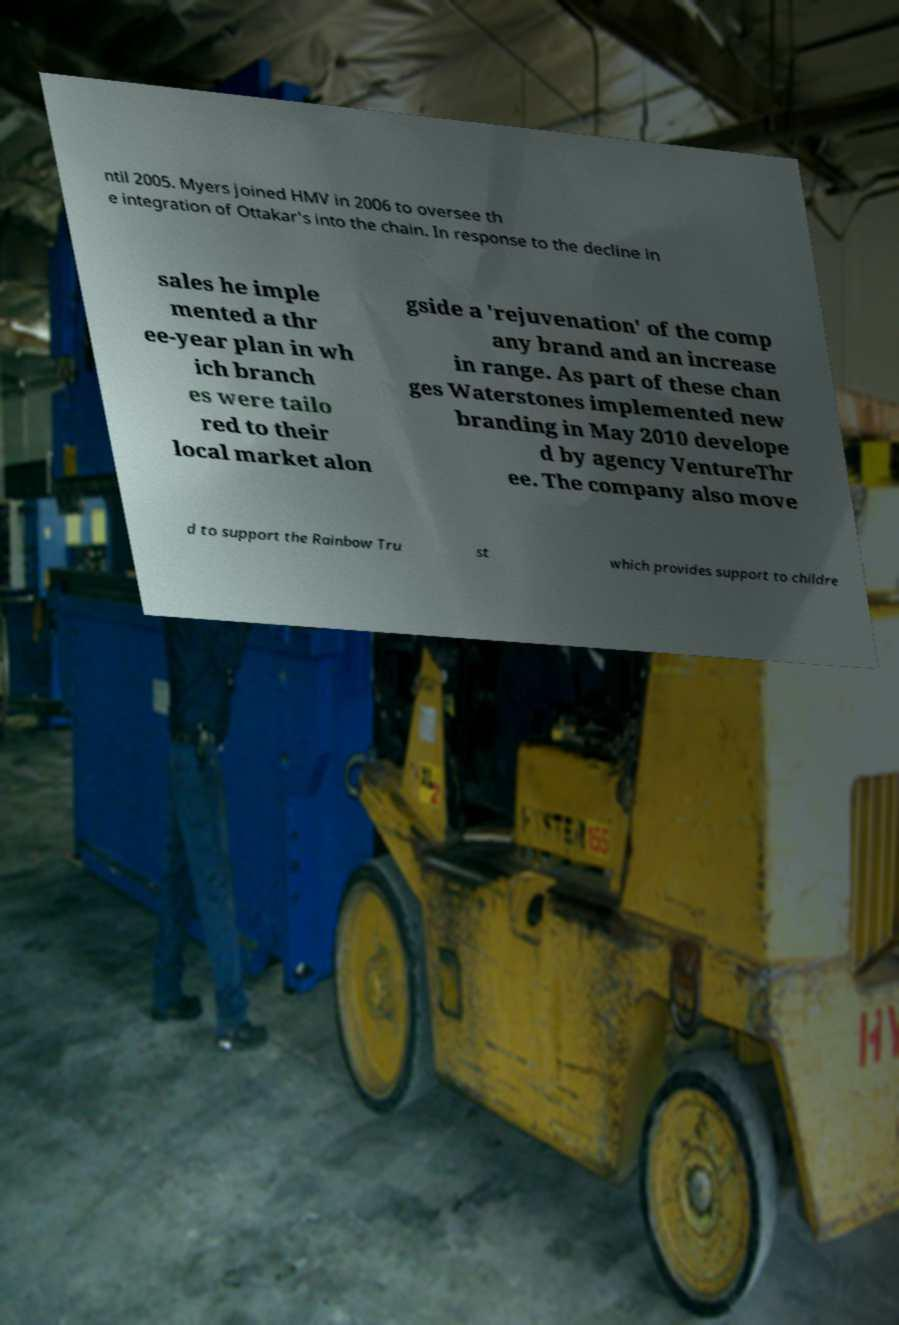What messages or text are displayed in this image? I need them in a readable, typed format. ntil 2005. Myers joined HMV in 2006 to oversee th e integration of Ottakar's into the chain. In response to the decline in sales he imple mented a thr ee-year plan in wh ich branch es were tailo red to their local market alon gside a 'rejuvenation' of the comp any brand and an increase in range. As part of these chan ges Waterstones implemented new branding in May 2010 develope d by agency VentureThr ee. The company also move d to support the Rainbow Tru st which provides support to childre 